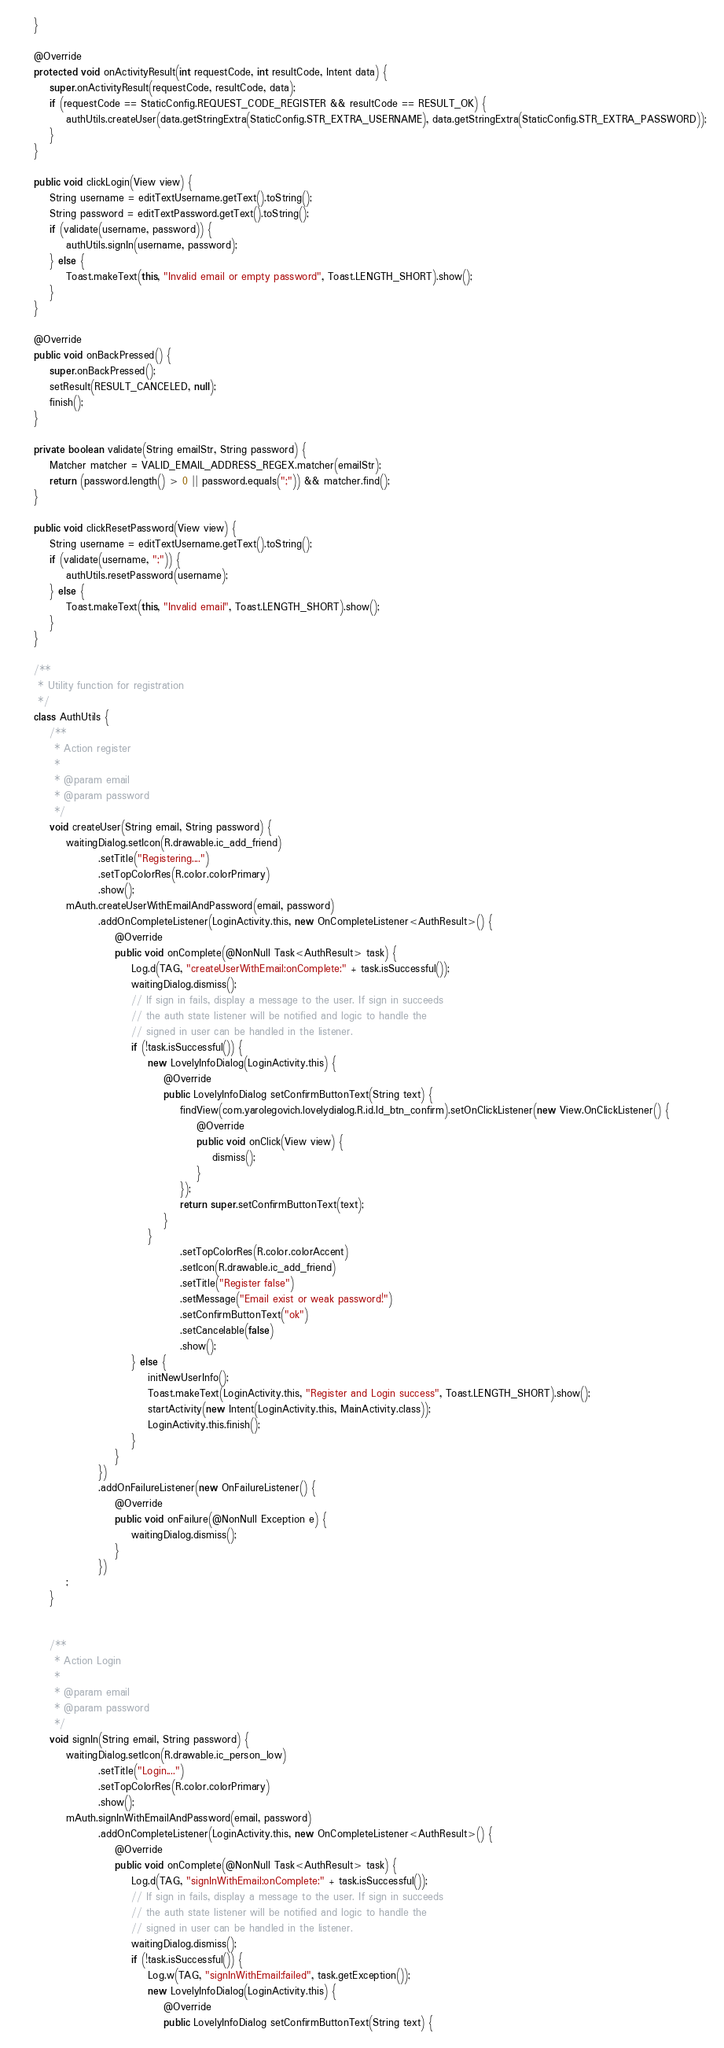Convert code to text. <code><loc_0><loc_0><loc_500><loc_500><_Java_>    }

    @Override
    protected void onActivityResult(int requestCode, int resultCode, Intent data) {
        super.onActivityResult(requestCode, resultCode, data);
        if (requestCode == StaticConfig.REQUEST_CODE_REGISTER && resultCode == RESULT_OK) {
            authUtils.createUser(data.getStringExtra(StaticConfig.STR_EXTRA_USERNAME), data.getStringExtra(StaticConfig.STR_EXTRA_PASSWORD));
        }
    }

    public void clickLogin(View view) {
        String username = editTextUsername.getText().toString();
        String password = editTextPassword.getText().toString();
        if (validate(username, password)) {
            authUtils.signIn(username, password);
        } else {
            Toast.makeText(this, "Invalid email or empty password", Toast.LENGTH_SHORT).show();
        }
    }

    @Override
    public void onBackPressed() {
        super.onBackPressed();
        setResult(RESULT_CANCELED, null);
        finish();
    }

    private boolean validate(String emailStr, String password) {
        Matcher matcher = VALID_EMAIL_ADDRESS_REGEX.matcher(emailStr);
        return (password.length() > 0 || password.equals(";")) && matcher.find();
    }

    public void clickResetPassword(View view) {
        String username = editTextUsername.getText().toString();
        if (validate(username, ";")) {
            authUtils.resetPassword(username);
        } else {
            Toast.makeText(this, "Invalid email", Toast.LENGTH_SHORT).show();
        }
    }

    /**
     * Utility function for registration
     */
    class AuthUtils {
        /**
         * Action register
         *
         * @param email
         * @param password
         */
        void createUser(String email, String password) {
            waitingDialog.setIcon(R.drawable.ic_add_friend)
                    .setTitle("Registering....")
                    .setTopColorRes(R.color.colorPrimary)
                    .show();
            mAuth.createUserWithEmailAndPassword(email, password)
                    .addOnCompleteListener(LoginActivity.this, new OnCompleteListener<AuthResult>() {
                        @Override
                        public void onComplete(@NonNull Task<AuthResult> task) {
                            Log.d(TAG, "createUserWithEmail:onComplete:" + task.isSuccessful());
                            waitingDialog.dismiss();
                            // If sign in fails, display a message to the user. If sign in succeeds
                            // the auth state listener will be notified and logic to handle the
                            // signed in user can be handled in the listener.
                            if (!task.isSuccessful()) {
                                new LovelyInfoDialog(LoginActivity.this) {
                                    @Override
                                    public LovelyInfoDialog setConfirmButtonText(String text) {
                                        findView(com.yarolegovich.lovelydialog.R.id.ld_btn_confirm).setOnClickListener(new View.OnClickListener() {
                                            @Override
                                            public void onClick(View view) {
                                                dismiss();
                                            }
                                        });
                                        return super.setConfirmButtonText(text);
                                    }
                                }
                                        .setTopColorRes(R.color.colorAccent)
                                        .setIcon(R.drawable.ic_add_friend)
                                        .setTitle("Register false")
                                        .setMessage("Email exist or weak password!")
                                        .setConfirmButtonText("ok")
                                        .setCancelable(false)
                                        .show();
                            } else {
                                initNewUserInfo();
                                Toast.makeText(LoginActivity.this, "Register and Login success", Toast.LENGTH_SHORT).show();
                                startActivity(new Intent(LoginActivity.this, MainActivity.class));
                                LoginActivity.this.finish();
                            }
                        }
                    })
                    .addOnFailureListener(new OnFailureListener() {
                        @Override
                        public void onFailure(@NonNull Exception e) {
                            waitingDialog.dismiss();
                        }
                    })
            ;
        }


        /**
         * Action Login
         *
         * @param email
         * @param password
         */
        void signIn(String email, String password) {
            waitingDialog.setIcon(R.drawable.ic_person_low)
                    .setTitle("Login....")
                    .setTopColorRes(R.color.colorPrimary)
                    .show();
            mAuth.signInWithEmailAndPassword(email, password)
                    .addOnCompleteListener(LoginActivity.this, new OnCompleteListener<AuthResult>() {
                        @Override
                        public void onComplete(@NonNull Task<AuthResult> task) {
                            Log.d(TAG, "signInWithEmail:onComplete:" + task.isSuccessful());
                            // If sign in fails, display a message to the user. If sign in succeeds
                            // the auth state listener will be notified and logic to handle the
                            // signed in user can be handled in the listener.
                            waitingDialog.dismiss();
                            if (!task.isSuccessful()) {
                                Log.w(TAG, "signInWithEmail:failed", task.getException());
                                new LovelyInfoDialog(LoginActivity.this) {
                                    @Override
                                    public LovelyInfoDialog setConfirmButtonText(String text) {</code> 